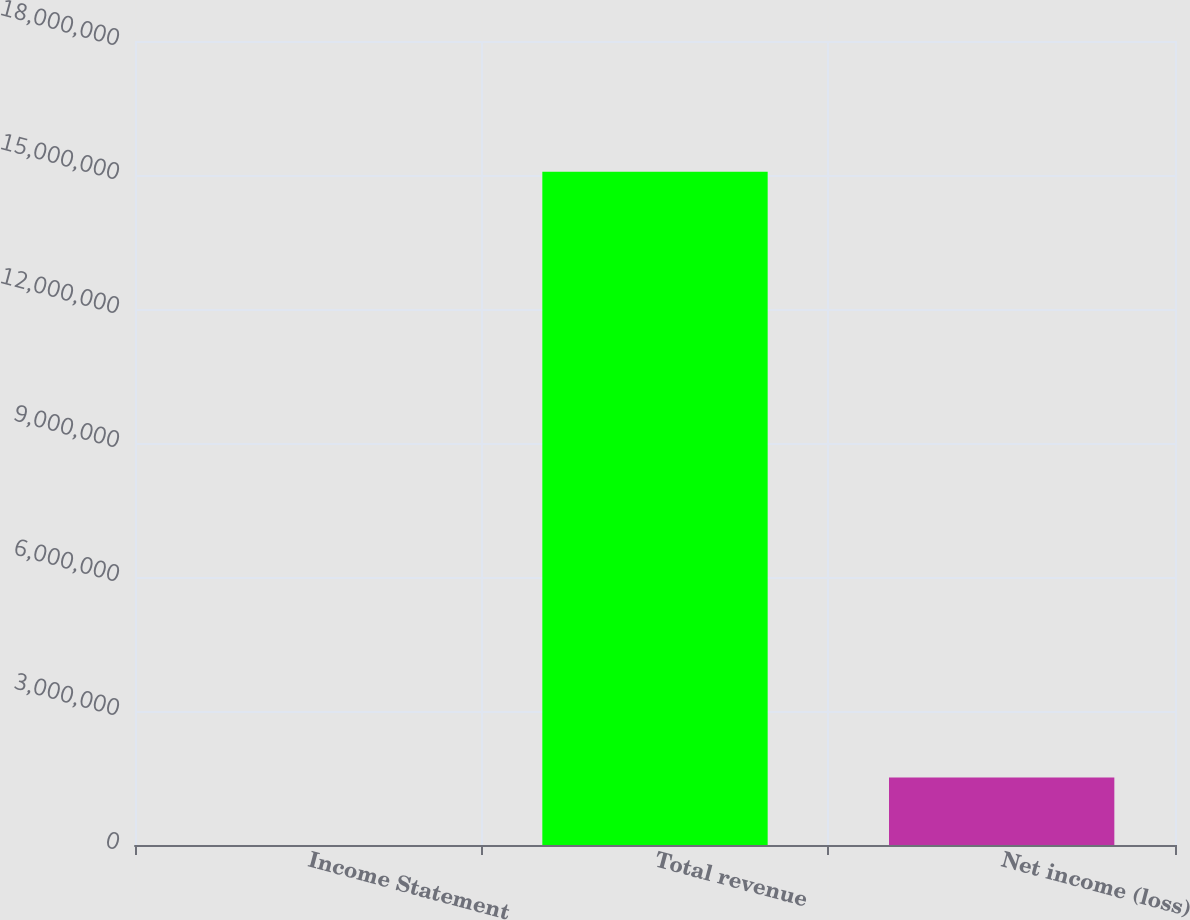Convert chart to OTSL. <chart><loc_0><loc_0><loc_500><loc_500><bar_chart><fcel>Income Statement<fcel>Total revenue<fcel>Net income (loss)<nl><fcel>2010<fcel>1.5074e+07<fcel>1.50921e+06<nl></chart> 